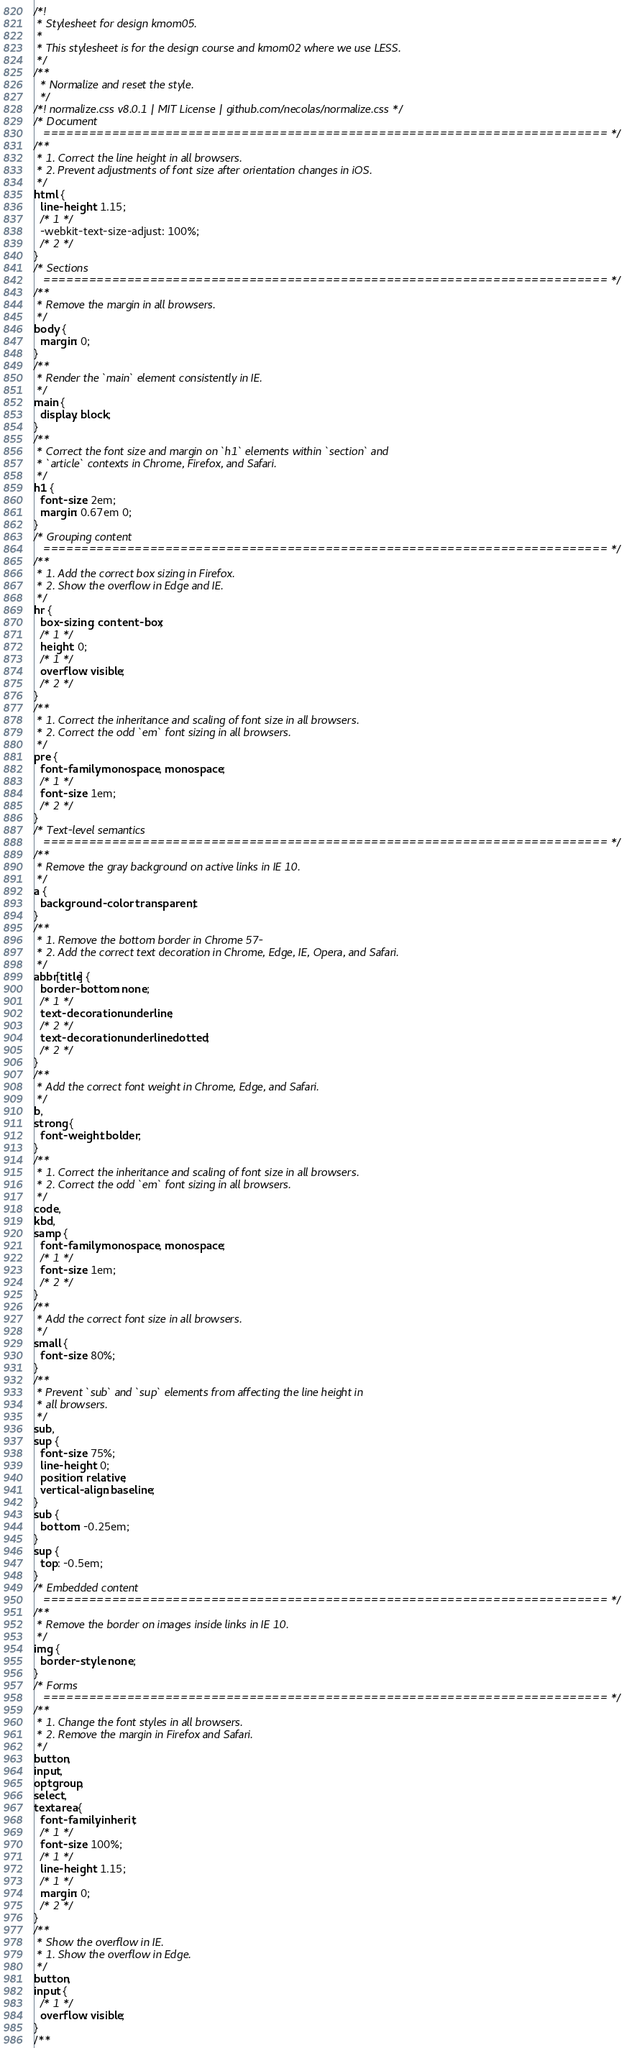Convert code to text. <code><loc_0><loc_0><loc_500><loc_500><_CSS_>/*!
 * Stylesheet for design kmom05.
 *
 * This stylesheet is for the design course and kmom02 where we use LESS.
 */
/**
  * Normalize and reset the style.
  */
/*! normalize.css v8.0.1 | MIT License | github.com/necolas/normalize.css */
/* Document
   ========================================================================== */
/**
 * 1. Correct the line height in all browsers.
 * 2. Prevent adjustments of font size after orientation changes in iOS.
 */
html {
  line-height: 1.15;
  /* 1 */
  -webkit-text-size-adjust: 100%;
  /* 2 */
}
/* Sections
   ========================================================================== */
/**
 * Remove the margin in all browsers.
 */
body {
  margin: 0;
}
/**
 * Render the `main` element consistently in IE.
 */
main {
  display: block;
}
/**
 * Correct the font size and margin on `h1` elements within `section` and
 * `article` contexts in Chrome, Firefox, and Safari.
 */
h1 {
  font-size: 2em;
  margin: 0.67em 0;
}
/* Grouping content
   ========================================================================== */
/**
 * 1. Add the correct box sizing in Firefox.
 * 2. Show the overflow in Edge and IE.
 */
hr {
  box-sizing: content-box;
  /* 1 */
  height: 0;
  /* 1 */
  overflow: visible;
  /* 2 */
}
/**
 * 1. Correct the inheritance and scaling of font size in all browsers.
 * 2. Correct the odd `em` font sizing in all browsers.
 */
pre {
  font-family: monospace, monospace;
  /* 1 */
  font-size: 1em;
  /* 2 */
}
/* Text-level semantics
   ========================================================================== */
/**
 * Remove the gray background on active links in IE 10.
 */
a {
  background-color: transparent;
}
/**
 * 1. Remove the bottom border in Chrome 57-
 * 2. Add the correct text decoration in Chrome, Edge, IE, Opera, and Safari.
 */
abbr[title] {
  border-bottom: none;
  /* 1 */
  text-decoration: underline;
  /* 2 */
  text-decoration: underline dotted;
  /* 2 */
}
/**
 * Add the correct font weight in Chrome, Edge, and Safari.
 */
b,
strong {
  font-weight: bolder;
}
/**
 * 1. Correct the inheritance and scaling of font size in all browsers.
 * 2. Correct the odd `em` font sizing in all browsers.
 */
code,
kbd,
samp {
  font-family: monospace, monospace;
  /* 1 */
  font-size: 1em;
  /* 2 */
}
/**
 * Add the correct font size in all browsers.
 */
small {
  font-size: 80%;
}
/**
 * Prevent `sub` and `sup` elements from affecting the line height in
 * all browsers.
 */
sub,
sup {
  font-size: 75%;
  line-height: 0;
  position: relative;
  vertical-align: baseline;
}
sub {
  bottom: -0.25em;
}
sup {
  top: -0.5em;
}
/* Embedded content
   ========================================================================== */
/**
 * Remove the border on images inside links in IE 10.
 */
img {
  border-style: none;
}
/* Forms
   ========================================================================== */
/**
 * 1. Change the font styles in all browsers.
 * 2. Remove the margin in Firefox and Safari.
 */
button,
input,
optgroup,
select,
textarea {
  font-family: inherit;
  /* 1 */
  font-size: 100%;
  /* 1 */
  line-height: 1.15;
  /* 1 */
  margin: 0;
  /* 2 */
}
/**
 * Show the overflow in IE.
 * 1. Show the overflow in Edge.
 */
button,
input {
  /* 1 */
  overflow: visible;
}
/**</code> 